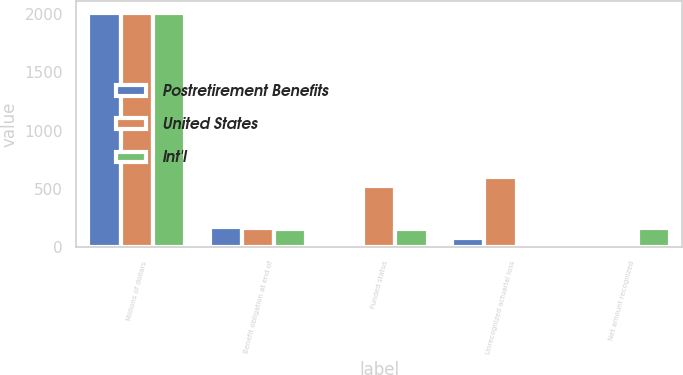Convert chart. <chart><loc_0><loc_0><loc_500><loc_500><stacked_bar_chart><ecel><fcel>Millions of dollars<fcel>Benefit obligation at end of<fcel>Funded status<fcel>Unrecognized actuarial loss<fcel>Net amount recognized<nl><fcel>Postretirement Benefits<fcel>2005<fcel>173<fcel>40<fcel>76<fcel>35<nl><fcel>United States<fcel>2005<fcel>163.5<fcel>523<fcel>602<fcel>14<nl><fcel>Int'l<fcel>2005<fcel>159<fcel>159<fcel>7<fcel>168<nl></chart> 